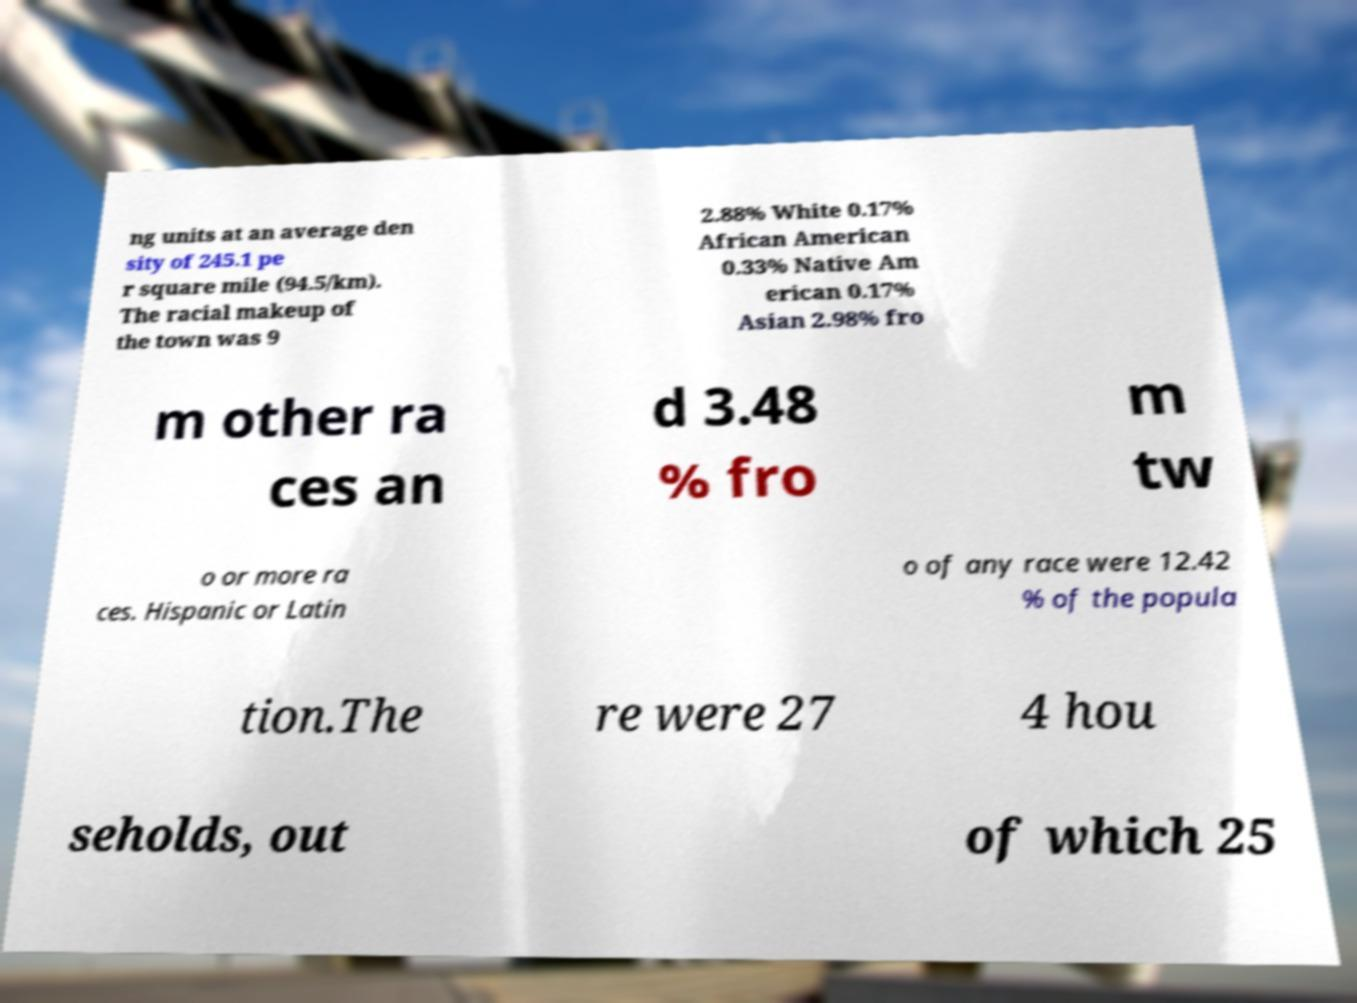Could you assist in decoding the text presented in this image and type it out clearly? ng units at an average den sity of 245.1 pe r square mile (94.5/km). The racial makeup of the town was 9 2.88% White 0.17% African American 0.33% Native Am erican 0.17% Asian 2.98% fro m other ra ces an d 3.48 % fro m tw o or more ra ces. Hispanic or Latin o of any race were 12.42 % of the popula tion.The re were 27 4 hou seholds, out of which 25 